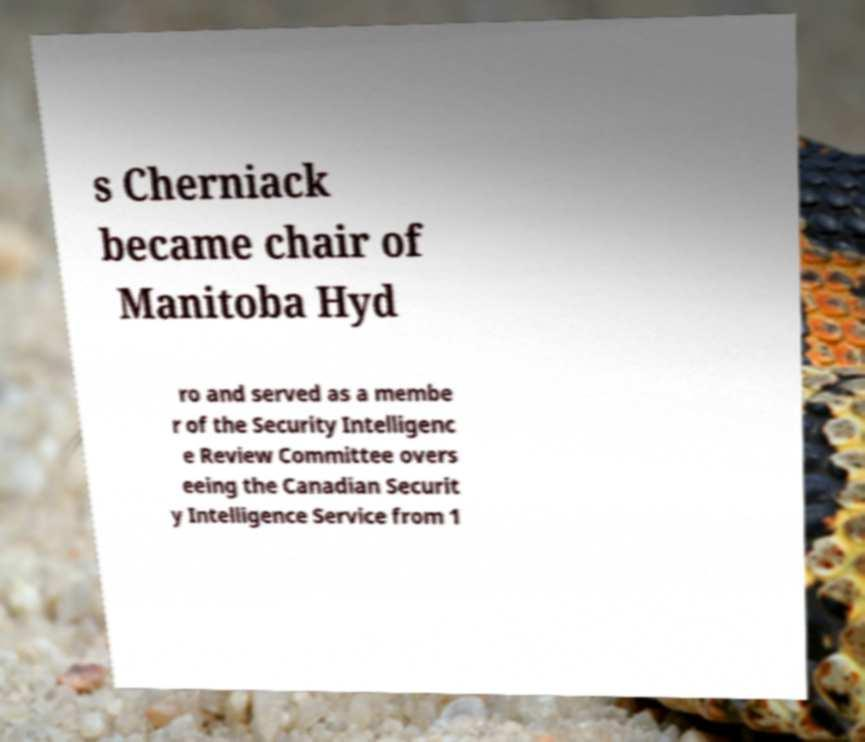Can you read and provide the text displayed in the image?This photo seems to have some interesting text. Can you extract and type it out for me? s Cherniack became chair of Manitoba Hyd ro and served as a membe r of the Security Intelligenc e Review Committee overs eeing the Canadian Securit y Intelligence Service from 1 